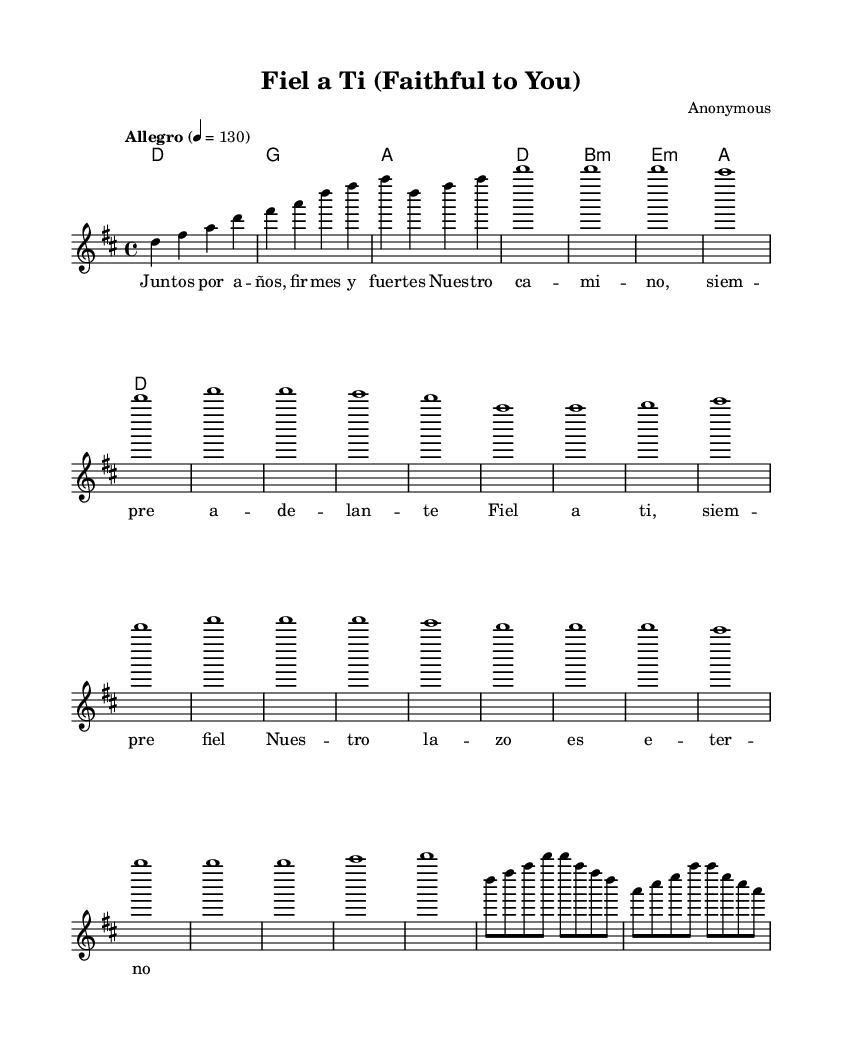What is the key signature of this music? The key signature is D major, which has two sharps (F# and C#). This can be determined by looking at the key signature indicated at the beginning of the score.
Answer: D major What is the time signature of this music? The time signature is 4/4, which means there are four beats in each measure, and the quarter note gets one beat. This can be found in the section that states " \time 4/4".
Answer: 4/4 What is the tempo marking of the piece? The tempo marking indicates "Allegro," which suggests a fast speed of play. The numerical representation "4 = 130" specifies the beats per minute. This is found in the header section of the score.
Answer: Allegro How many measures are in the melody section? The melody section consists of six measures as indicated by the division of notes and bars throughout that part of the score. To count the measures, one would look for the vertical bar lines that separate them.
Answer: 6 Which lyrical theme is highlighted in the chorus? The lyrical theme highlighted in the chorus emphasizes loyalty, as seen in the repeated phrase "Fiel a ti" (Faithful to you) throughout the lyrics. This reflects the central message of loyalty in relationships found in the songs of the Salsa genre.
Answer: Loyalty What is the chord progression used in the harmonies? The chord progression is D, G, A, D, B minor, E minor, A, D. This can be deduced by analyzing the sequence of chords listed under the "harmonies" section in the sheet music.
Answer: D, G, A, D, B minor, E minor, A, D What does the term "montuno" refer to in this piece? "Montuno" refers to a repeated musical phrase that often enhances the rhythm and texture in a Salsa piece. In this case, it's a dynamic section that complements the thematic material and energetic feel of the music. This term can be spotted in the structure of the piece.
Answer: Repeated phrase 